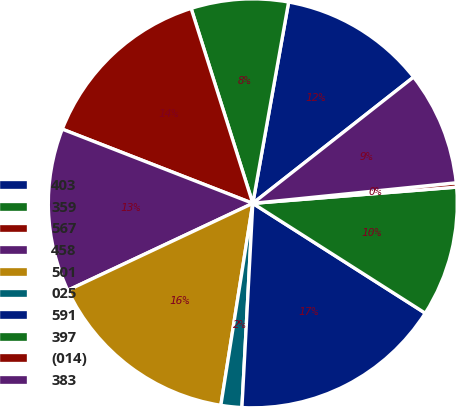Convert chart. <chart><loc_0><loc_0><loc_500><loc_500><pie_chart><fcel>403<fcel>359<fcel>567<fcel>458<fcel>501<fcel>025<fcel>591<fcel>397<fcel>(014)<fcel>383<nl><fcel>11.6%<fcel>7.68%<fcel>14.21%<fcel>12.9%<fcel>15.51%<fcel>1.65%<fcel>16.82%<fcel>10.29%<fcel>0.34%<fcel>8.99%<nl></chart> 